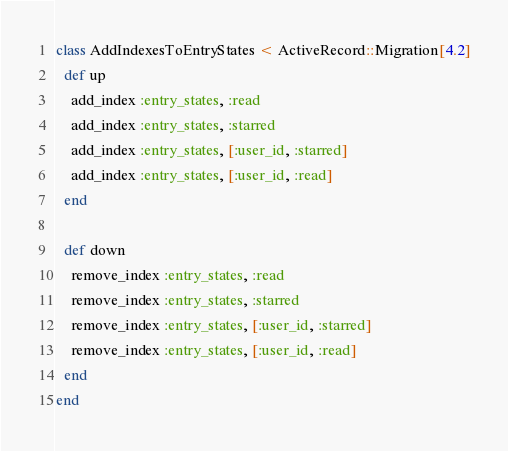<code> <loc_0><loc_0><loc_500><loc_500><_Ruby_>class AddIndexesToEntryStates < ActiveRecord::Migration[4.2]
  def up
    add_index :entry_states, :read
    add_index :entry_states, :starred
    add_index :entry_states, [:user_id, :starred]
    add_index :entry_states, [:user_id, :read]
  end

  def down
    remove_index :entry_states, :read
    remove_index :entry_states, :starred
    remove_index :entry_states, [:user_id, :starred]
    remove_index :entry_states, [:user_id, :read]
  end
end
</code> 